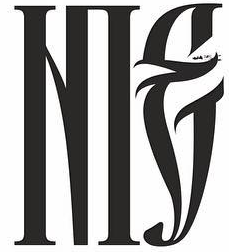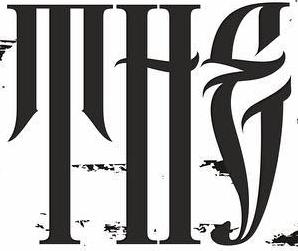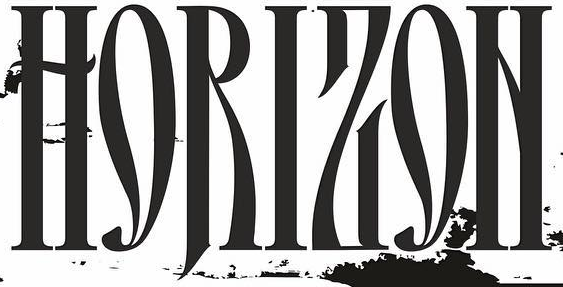What text is displayed in these images sequentially, separated by a semicolon? NIE; THE; HORIZON 